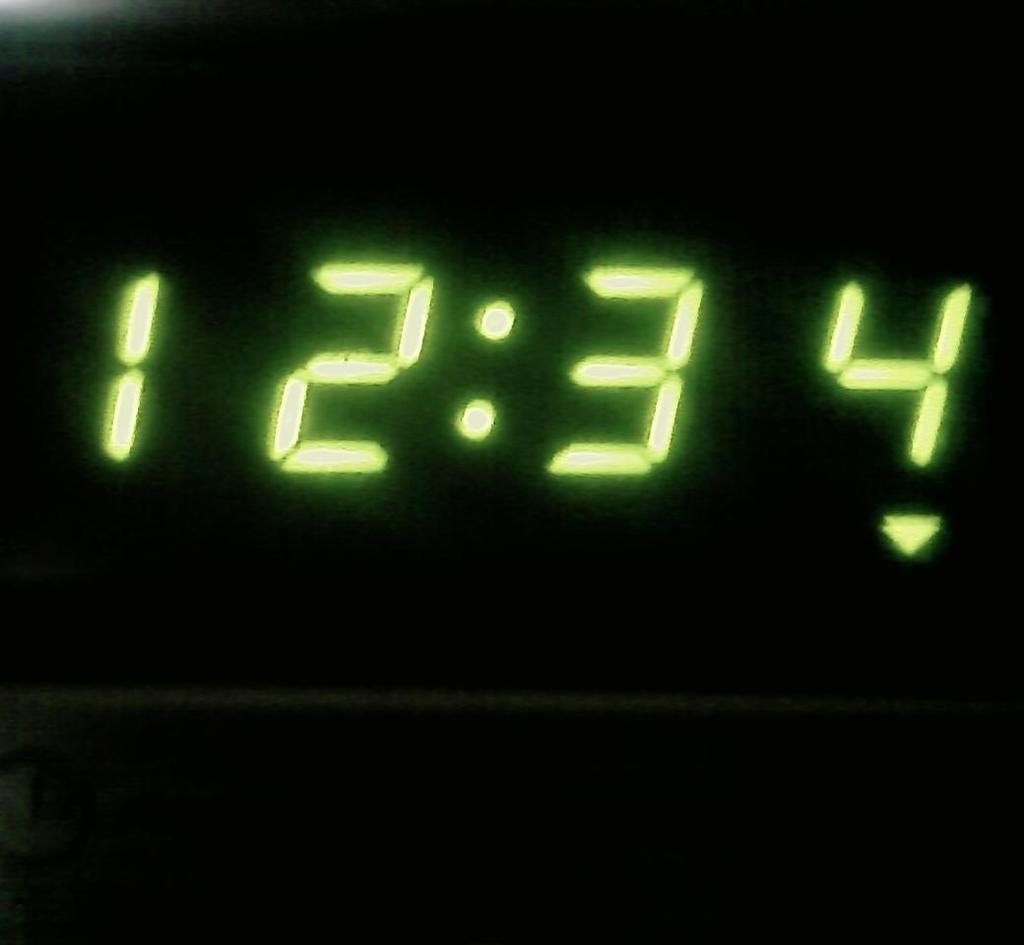<image>
Provide a brief description of the given image. A digital clock has yellow-green numbers that say the time is 12:34. 